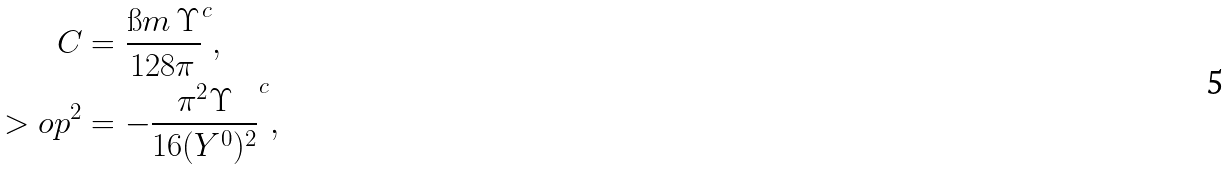Convert formula to latex. <formula><loc_0><loc_0><loc_500><loc_500>C & = \frac { \i m \, \Upsilon } { 1 2 8 \pi } ^ { c } , \\ > o p ^ { 2 } & = - \frac { \pi ^ { 2 } \Upsilon } { 1 6 ( Y ^ { 0 } ) ^ { 2 } } ^ { c } ,</formula> 